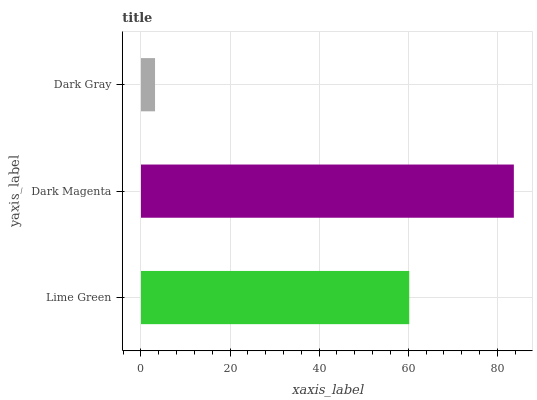Is Dark Gray the minimum?
Answer yes or no. Yes. Is Dark Magenta the maximum?
Answer yes or no. Yes. Is Dark Magenta the minimum?
Answer yes or no. No. Is Dark Gray the maximum?
Answer yes or no. No. Is Dark Magenta greater than Dark Gray?
Answer yes or no. Yes. Is Dark Gray less than Dark Magenta?
Answer yes or no. Yes. Is Dark Gray greater than Dark Magenta?
Answer yes or no. No. Is Dark Magenta less than Dark Gray?
Answer yes or no. No. Is Lime Green the high median?
Answer yes or no. Yes. Is Lime Green the low median?
Answer yes or no. Yes. Is Dark Gray the high median?
Answer yes or no. No. Is Dark Gray the low median?
Answer yes or no. No. 